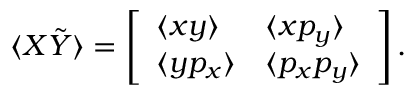Convert formula to latex. <formula><loc_0><loc_0><loc_500><loc_500>\langle X \tilde { Y } \rangle = \left [ \begin{array} { l l } { \langle x y \rangle } & { \langle x p _ { y } \rangle } \\ { \langle y p _ { x } \rangle } & { \langle p _ { x } p _ { y } \rangle } \end{array} \right ] .</formula> 